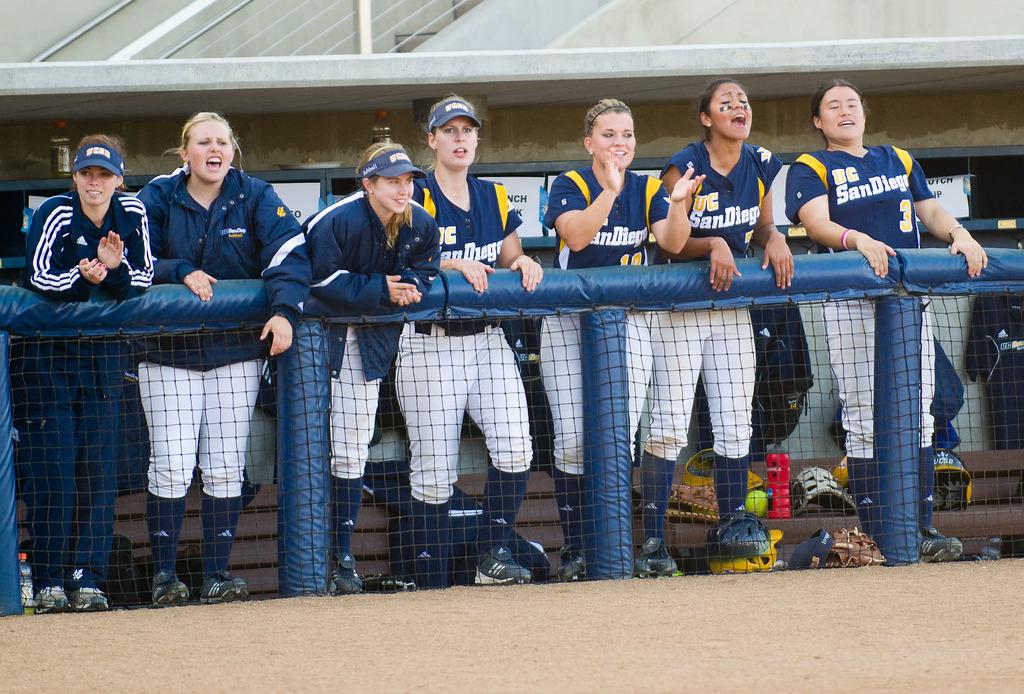What number is the player all the way to the right?
Give a very brief answer. 3. 